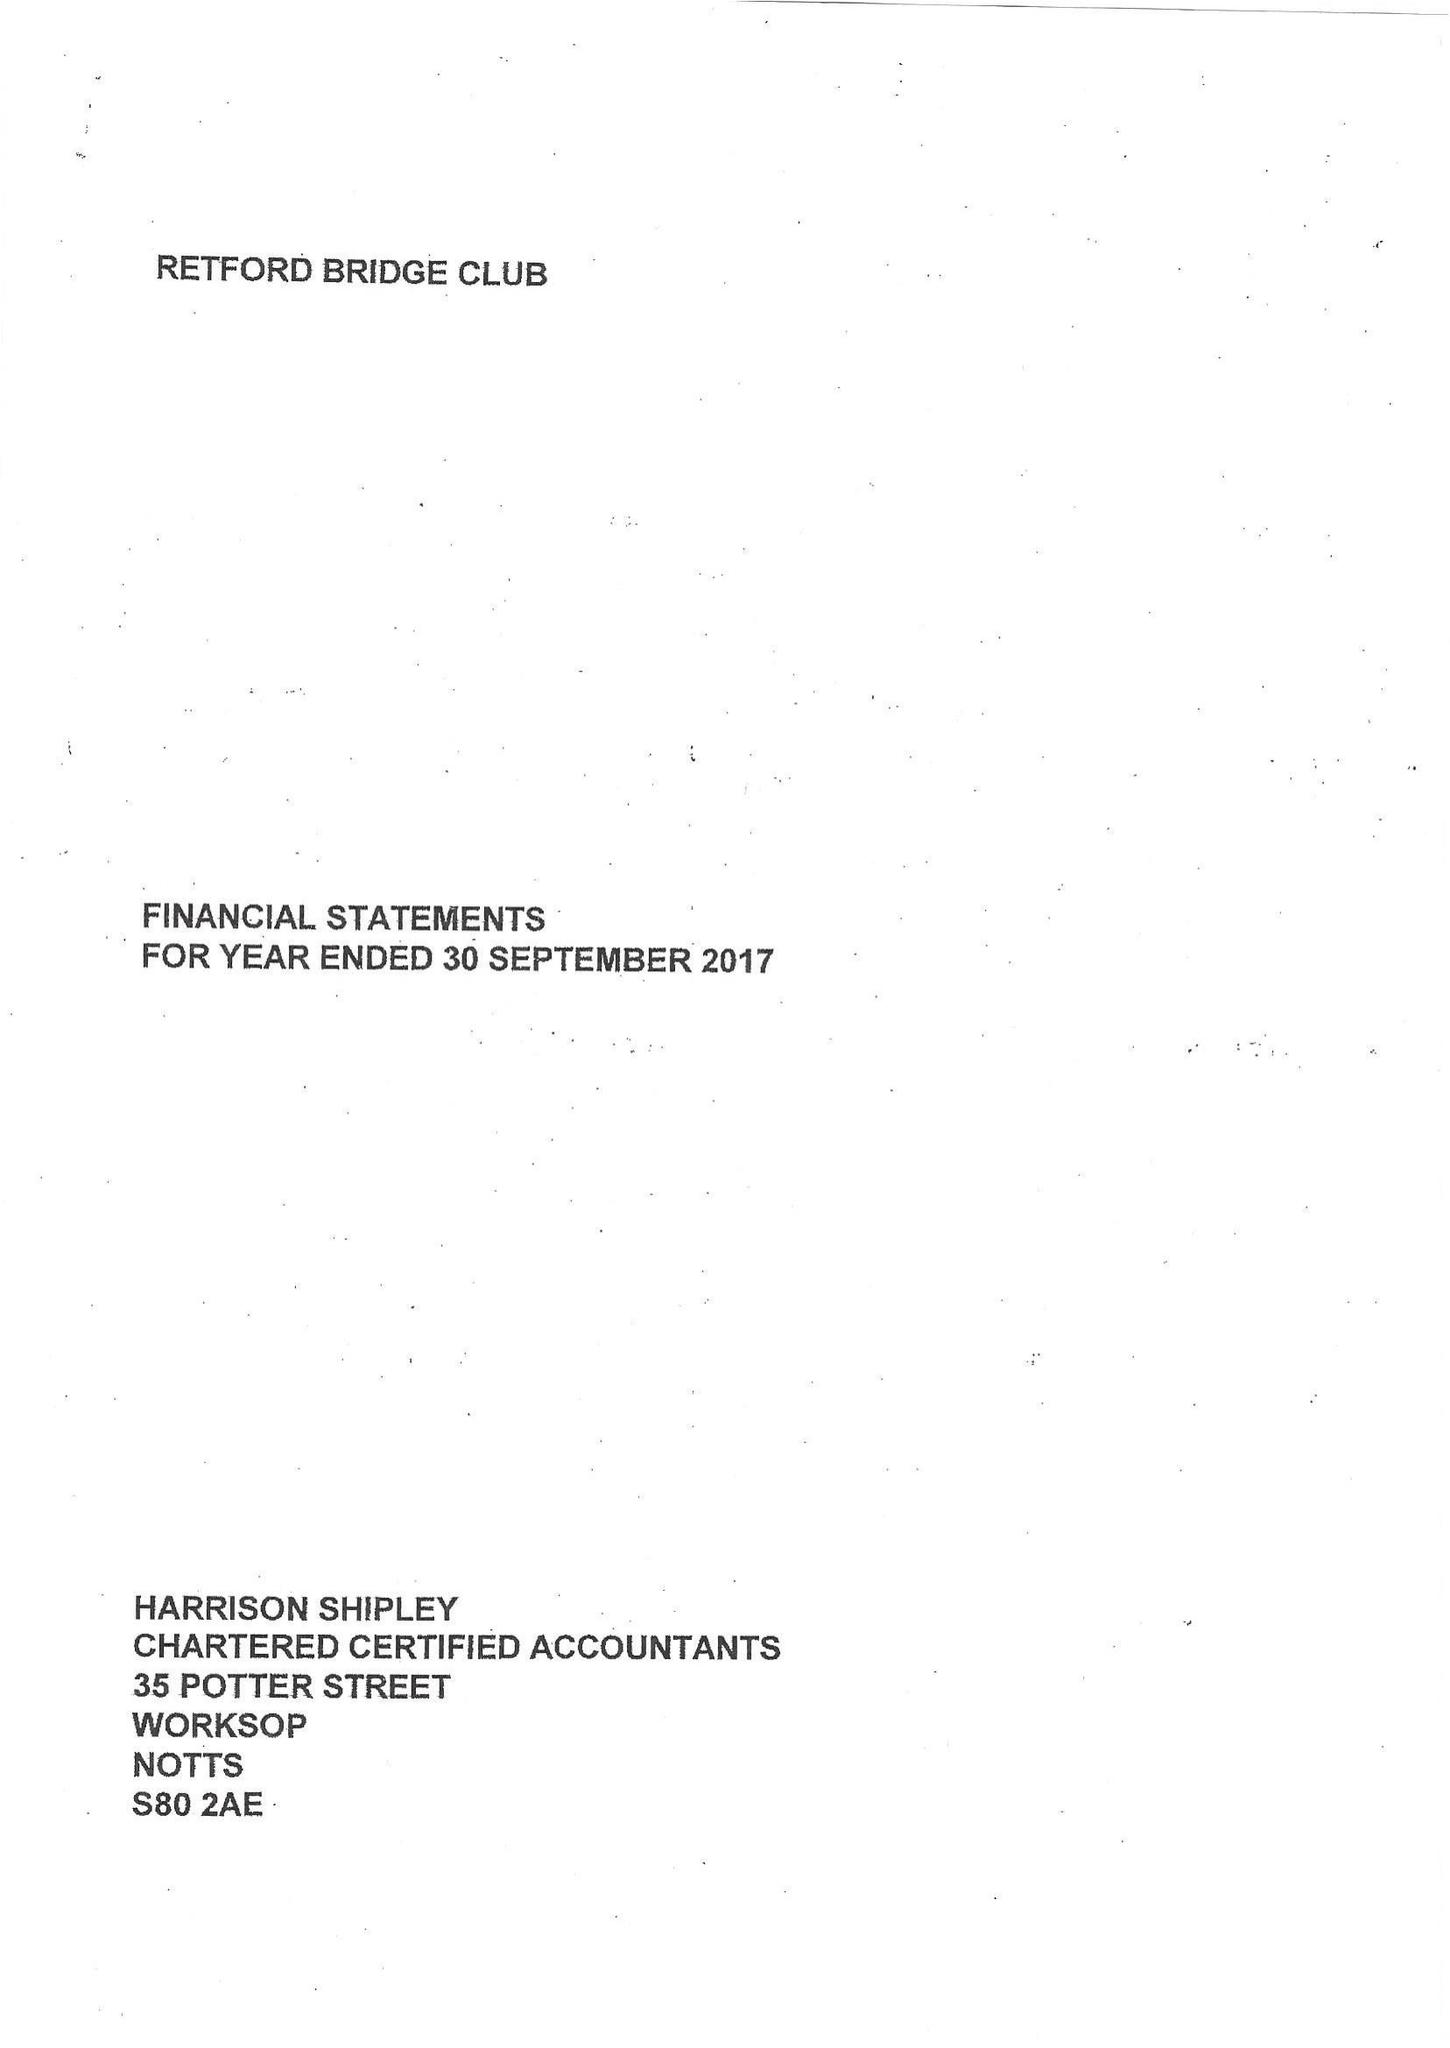What is the value for the charity_number?
Answer the question using a single word or phrase. 1166225 